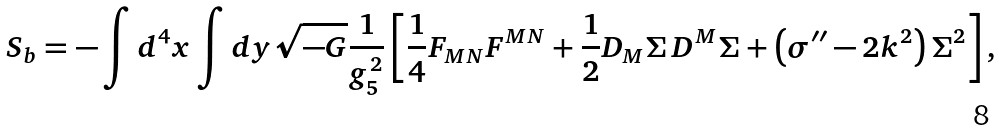<formula> <loc_0><loc_0><loc_500><loc_500>S _ { b } = - \int d ^ { 4 } x \int d y \sqrt { - G } \frac { 1 } { g _ { 5 } ^ { 2 } } \left [ \frac { 1 } { 4 } F _ { M N } F ^ { M N } + \frac { 1 } { 2 } D _ { M } \Sigma \, D ^ { M } \Sigma + \left ( \sigma ^ { \prime \prime } - 2 k ^ { 2 } \right ) \Sigma ^ { 2 } \right ] ,</formula> 